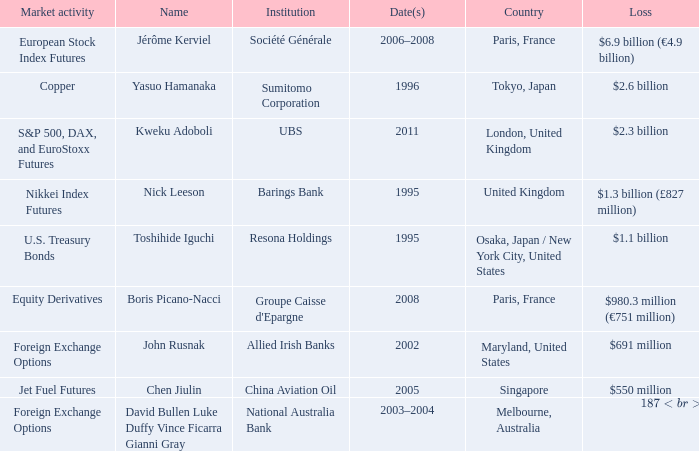What was the loss for Boris Picano-Nacci? $980.3 million (€751 million). 